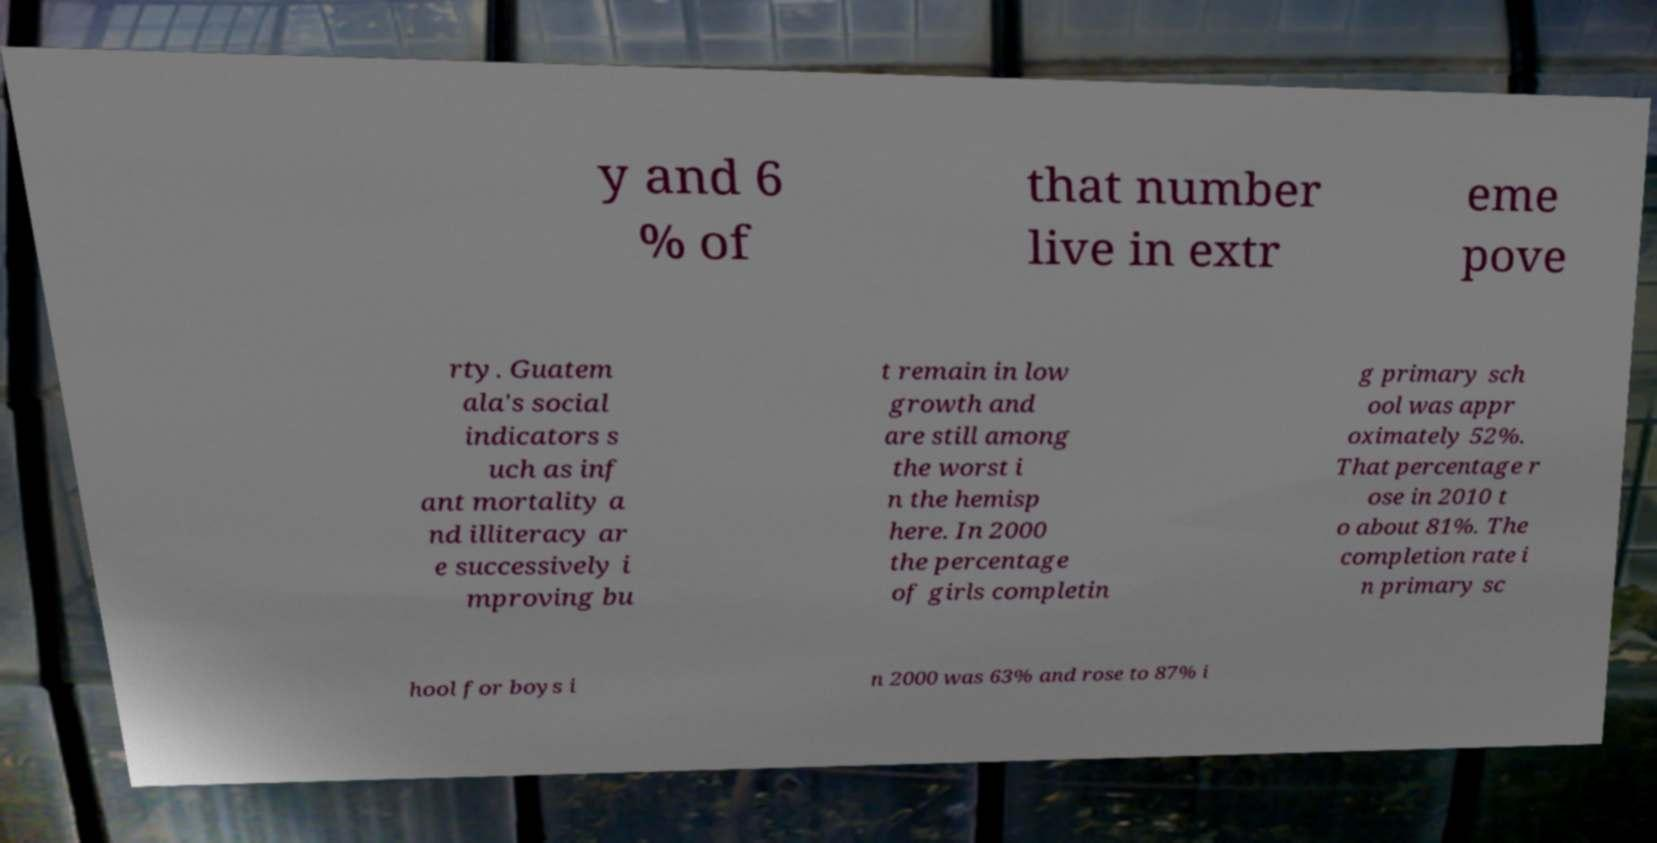Can you read and provide the text displayed in the image?This photo seems to have some interesting text. Can you extract and type it out for me? y and 6 % of that number live in extr eme pove rty. Guatem ala's social indicators s uch as inf ant mortality a nd illiteracy ar e successively i mproving bu t remain in low growth and are still among the worst i n the hemisp here. In 2000 the percentage of girls completin g primary sch ool was appr oximately 52%. That percentage r ose in 2010 t o about 81%. The completion rate i n primary sc hool for boys i n 2000 was 63% and rose to 87% i 